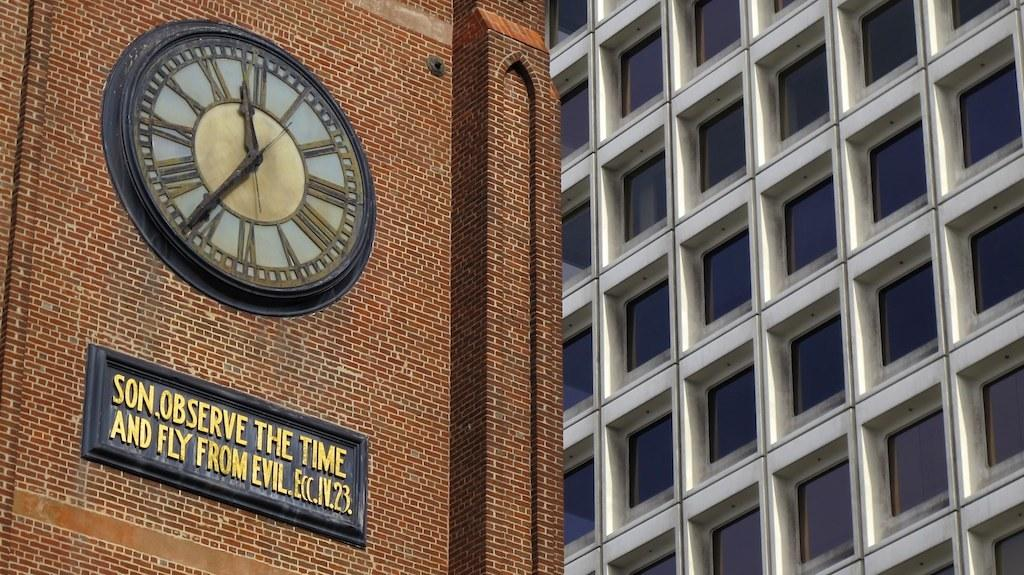<image>
Write a terse but informative summary of the picture. A clock has a sign below it that begins, Son, Observe the Time and Fly from Evil. 